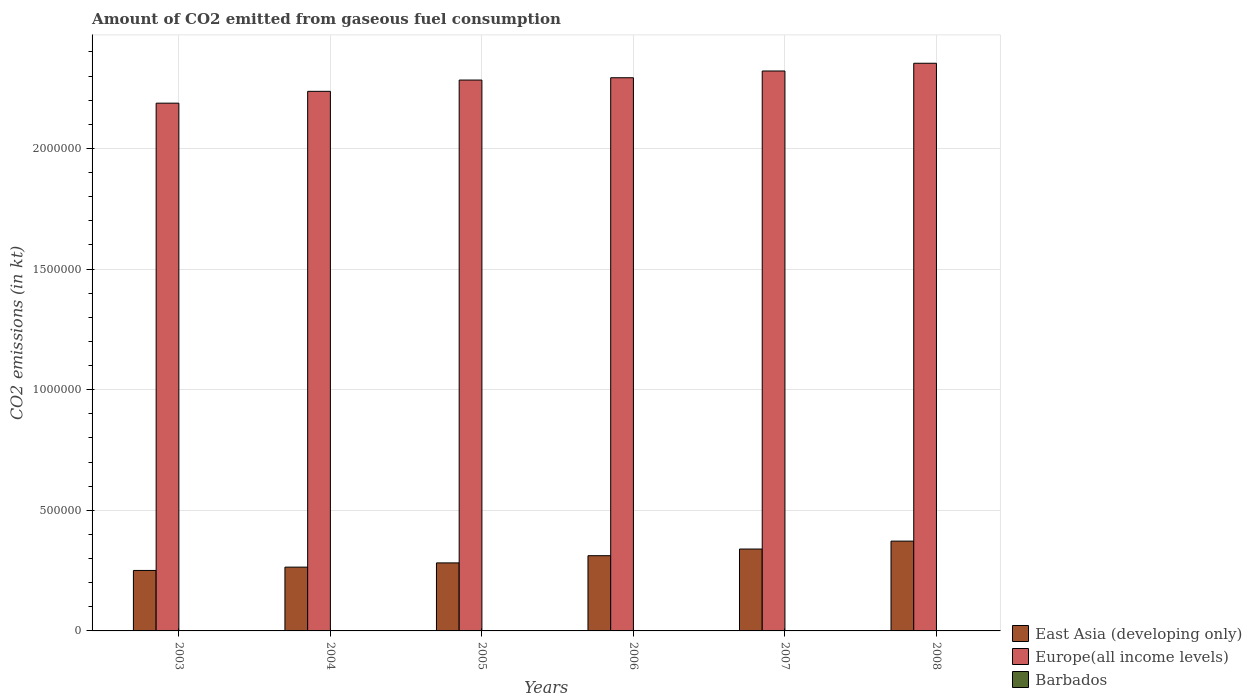Are the number of bars on each tick of the X-axis equal?
Provide a short and direct response. Yes. In how many cases, is the number of bars for a given year not equal to the number of legend labels?
Make the answer very short. 0. What is the amount of CO2 emitted in Europe(all income levels) in 2004?
Keep it short and to the point. 2.24e+06. Across all years, what is the maximum amount of CO2 emitted in Barbados?
Provide a succinct answer. 51.34. Across all years, what is the minimum amount of CO2 emitted in Barbados?
Offer a very short reply. 44. In which year was the amount of CO2 emitted in Barbados maximum?
Offer a terse response. 2005. What is the total amount of CO2 emitted in Barbados in the graph?
Keep it short and to the point. 293.36. What is the difference between the amount of CO2 emitted in East Asia (developing only) in 2004 and that in 2006?
Offer a terse response. -4.74e+04. What is the difference between the amount of CO2 emitted in Europe(all income levels) in 2008 and the amount of CO2 emitted in Barbados in 2005?
Keep it short and to the point. 2.35e+06. What is the average amount of CO2 emitted in Barbados per year?
Provide a succinct answer. 48.89. In the year 2005, what is the difference between the amount of CO2 emitted in Barbados and amount of CO2 emitted in Europe(all income levels)?
Offer a terse response. -2.28e+06. What is the ratio of the amount of CO2 emitted in East Asia (developing only) in 2005 to that in 2007?
Ensure brevity in your answer.  0.83. Is the amount of CO2 emitted in East Asia (developing only) in 2003 less than that in 2007?
Give a very brief answer. Yes. Is the difference between the amount of CO2 emitted in Barbados in 2003 and 2005 greater than the difference between the amount of CO2 emitted in Europe(all income levels) in 2003 and 2005?
Make the answer very short. Yes. What is the difference between the highest and the lowest amount of CO2 emitted in Barbados?
Your answer should be compact. 7.33. What does the 1st bar from the left in 2006 represents?
Your answer should be compact. East Asia (developing only). What does the 3rd bar from the right in 2006 represents?
Your answer should be very brief. East Asia (developing only). Is it the case that in every year, the sum of the amount of CO2 emitted in Europe(all income levels) and amount of CO2 emitted in Barbados is greater than the amount of CO2 emitted in East Asia (developing only)?
Provide a short and direct response. Yes. How many bars are there?
Ensure brevity in your answer.  18. Are all the bars in the graph horizontal?
Give a very brief answer. No. How many years are there in the graph?
Your answer should be very brief. 6. What is the difference between two consecutive major ticks on the Y-axis?
Your answer should be compact. 5.00e+05. Does the graph contain grids?
Keep it short and to the point. Yes. Where does the legend appear in the graph?
Offer a very short reply. Bottom right. How are the legend labels stacked?
Make the answer very short. Vertical. What is the title of the graph?
Your answer should be compact. Amount of CO2 emitted from gaseous fuel consumption. Does "India" appear as one of the legend labels in the graph?
Ensure brevity in your answer.  No. What is the label or title of the X-axis?
Ensure brevity in your answer.  Years. What is the label or title of the Y-axis?
Keep it short and to the point. CO2 emissions (in kt). What is the CO2 emissions (in kt) of East Asia (developing only) in 2003?
Ensure brevity in your answer.  2.51e+05. What is the CO2 emissions (in kt) in Europe(all income levels) in 2003?
Give a very brief answer. 2.19e+06. What is the CO2 emissions (in kt) of Barbados in 2003?
Ensure brevity in your answer.  47.67. What is the CO2 emissions (in kt) of East Asia (developing only) in 2004?
Your answer should be very brief. 2.64e+05. What is the CO2 emissions (in kt) of Europe(all income levels) in 2004?
Offer a very short reply. 2.24e+06. What is the CO2 emissions (in kt) in Barbados in 2004?
Offer a very short reply. 47.67. What is the CO2 emissions (in kt) of East Asia (developing only) in 2005?
Ensure brevity in your answer.  2.82e+05. What is the CO2 emissions (in kt) in Europe(all income levels) in 2005?
Your answer should be compact. 2.28e+06. What is the CO2 emissions (in kt) of Barbados in 2005?
Offer a very short reply. 51.34. What is the CO2 emissions (in kt) in East Asia (developing only) in 2006?
Keep it short and to the point. 3.12e+05. What is the CO2 emissions (in kt) in Europe(all income levels) in 2006?
Your answer should be very brief. 2.29e+06. What is the CO2 emissions (in kt) of Barbados in 2006?
Make the answer very short. 51.34. What is the CO2 emissions (in kt) in East Asia (developing only) in 2007?
Provide a short and direct response. 3.39e+05. What is the CO2 emissions (in kt) of Europe(all income levels) in 2007?
Provide a short and direct response. 2.32e+06. What is the CO2 emissions (in kt) of Barbados in 2007?
Offer a terse response. 44. What is the CO2 emissions (in kt) in East Asia (developing only) in 2008?
Keep it short and to the point. 3.72e+05. What is the CO2 emissions (in kt) of Europe(all income levels) in 2008?
Your answer should be very brief. 2.35e+06. What is the CO2 emissions (in kt) of Barbados in 2008?
Ensure brevity in your answer.  51.34. Across all years, what is the maximum CO2 emissions (in kt) in East Asia (developing only)?
Make the answer very short. 3.72e+05. Across all years, what is the maximum CO2 emissions (in kt) of Europe(all income levels)?
Keep it short and to the point. 2.35e+06. Across all years, what is the maximum CO2 emissions (in kt) in Barbados?
Provide a succinct answer. 51.34. Across all years, what is the minimum CO2 emissions (in kt) of East Asia (developing only)?
Make the answer very short. 2.51e+05. Across all years, what is the minimum CO2 emissions (in kt) in Europe(all income levels)?
Your response must be concise. 2.19e+06. Across all years, what is the minimum CO2 emissions (in kt) in Barbados?
Your answer should be very brief. 44. What is the total CO2 emissions (in kt) of East Asia (developing only) in the graph?
Provide a succinct answer. 1.82e+06. What is the total CO2 emissions (in kt) in Europe(all income levels) in the graph?
Give a very brief answer. 1.37e+07. What is the total CO2 emissions (in kt) of Barbados in the graph?
Provide a succinct answer. 293.36. What is the difference between the CO2 emissions (in kt) of East Asia (developing only) in 2003 and that in 2004?
Give a very brief answer. -1.37e+04. What is the difference between the CO2 emissions (in kt) of Europe(all income levels) in 2003 and that in 2004?
Keep it short and to the point. -4.90e+04. What is the difference between the CO2 emissions (in kt) of Barbados in 2003 and that in 2004?
Keep it short and to the point. 0. What is the difference between the CO2 emissions (in kt) in East Asia (developing only) in 2003 and that in 2005?
Keep it short and to the point. -3.13e+04. What is the difference between the CO2 emissions (in kt) in Europe(all income levels) in 2003 and that in 2005?
Provide a short and direct response. -9.58e+04. What is the difference between the CO2 emissions (in kt) of Barbados in 2003 and that in 2005?
Offer a terse response. -3.67. What is the difference between the CO2 emissions (in kt) in East Asia (developing only) in 2003 and that in 2006?
Ensure brevity in your answer.  -6.11e+04. What is the difference between the CO2 emissions (in kt) in Europe(all income levels) in 2003 and that in 2006?
Provide a succinct answer. -1.05e+05. What is the difference between the CO2 emissions (in kt) of Barbados in 2003 and that in 2006?
Keep it short and to the point. -3.67. What is the difference between the CO2 emissions (in kt) in East Asia (developing only) in 2003 and that in 2007?
Give a very brief answer. -8.87e+04. What is the difference between the CO2 emissions (in kt) in Europe(all income levels) in 2003 and that in 2007?
Provide a succinct answer. -1.33e+05. What is the difference between the CO2 emissions (in kt) of Barbados in 2003 and that in 2007?
Make the answer very short. 3.67. What is the difference between the CO2 emissions (in kt) in East Asia (developing only) in 2003 and that in 2008?
Your answer should be very brief. -1.22e+05. What is the difference between the CO2 emissions (in kt) in Europe(all income levels) in 2003 and that in 2008?
Offer a very short reply. -1.65e+05. What is the difference between the CO2 emissions (in kt) in Barbados in 2003 and that in 2008?
Offer a terse response. -3.67. What is the difference between the CO2 emissions (in kt) of East Asia (developing only) in 2004 and that in 2005?
Make the answer very short. -1.76e+04. What is the difference between the CO2 emissions (in kt) in Europe(all income levels) in 2004 and that in 2005?
Make the answer very short. -4.68e+04. What is the difference between the CO2 emissions (in kt) of Barbados in 2004 and that in 2005?
Give a very brief answer. -3.67. What is the difference between the CO2 emissions (in kt) of East Asia (developing only) in 2004 and that in 2006?
Your response must be concise. -4.74e+04. What is the difference between the CO2 emissions (in kt) in Europe(all income levels) in 2004 and that in 2006?
Offer a very short reply. -5.64e+04. What is the difference between the CO2 emissions (in kt) of Barbados in 2004 and that in 2006?
Your response must be concise. -3.67. What is the difference between the CO2 emissions (in kt) of East Asia (developing only) in 2004 and that in 2007?
Provide a short and direct response. -7.50e+04. What is the difference between the CO2 emissions (in kt) of Europe(all income levels) in 2004 and that in 2007?
Your answer should be very brief. -8.43e+04. What is the difference between the CO2 emissions (in kt) in Barbados in 2004 and that in 2007?
Ensure brevity in your answer.  3.67. What is the difference between the CO2 emissions (in kt) of East Asia (developing only) in 2004 and that in 2008?
Keep it short and to the point. -1.08e+05. What is the difference between the CO2 emissions (in kt) of Europe(all income levels) in 2004 and that in 2008?
Your answer should be compact. -1.16e+05. What is the difference between the CO2 emissions (in kt) in Barbados in 2004 and that in 2008?
Provide a short and direct response. -3.67. What is the difference between the CO2 emissions (in kt) in East Asia (developing only) in 2005 and that in 2006?
Provide a succinct answer. -2.99e+04. What is the difference between the CO2 emissions (in kt) of Europe(all income levels) in 2005 and that in 2006?
Your answer should be very brief. -9615.06. What is the difference between the CO2 emissions (in kt) of Barbados in 2005 and that in 2006?
Offer a very short reply. 0. What is the difference between the CO2 emissions (in kt) of East Asia (developing only) in 2005 and that in 2007?
Give a very brief answer. -5.74e+04. What is the difference between the CO2 emissions (in kt) of Europe(all income levels) in 2005 and that in 2007?
Your answer should be very brief. -3.75e+04. What is the difference between the CO2 emissions (in kt) of Barbados in 2005 and that in 2007?
Provide a short and direct response. 7.33. What is the difference between the CO2 emissions (in kt) of East Asia (developing only) in 2005 and that in 2008?
Make the answer very short. -9.03e+04. What is the difference between the CO2 emissions (in kt) of Europe(all income levels) in 2005 and that in 2008?
Offer a very short reply. -6.96e+04. What is the difference between the CO2 emissions (in kt) of Barbados in 2005 and that in 2008?
Your response must be concise. 0. What is the difference between the CO2 emissions (in kt) of East Asia (developing only) in 2006 and that in 2007?
Provide a short and direct response. -2.75e+04. What is the difference between the CO2 emissions (in kt) of Europe(all income levels) in 2006 and that in 2007?
Give a very brief answer. -2.79e+04. What is the difference between the CO2 emissions (in kt) of Barbados in 2006 and that in 2007?
Offer a very short reply. 7.33. What is the difference between the CO2 emissions (in kt) in East Asia (developing only) in 2006 and that in 2008?
Offer a very short reply. -6.04e+04. What is the difference between the CO2 emissions (in kt) in Europe(all income levels) in 2006 and that in 2008?
Offer a very short reply. -6.00e+04. What is the difference between the CO2 emissions (in kt) in Barbados in 2006 and that in 2008?
Make the answer very short. 0. What is the difference between the CO2 emissions (in kt) in East Asia (developing only) in 2007 and that in 2008?
Provide a succinct answer. -3.29e+04. What is the difference between the CO2 emissions (in kt) of Europe(all income levels) in 2007 and that in 2008?
Keep it short and to the point. -3.21e+04. What is the difference between the CO2 emissions (in kt) of Barbados in 2007 and that in 2008?
Your answer should be very brief. -7.33. What is the difference between the CO2 emissions (in kt) of East Asia (developing only) in 2003 and the CO2 emissions (in kt) of Europe(all income levels) in 2004?
Keep it short and to the point. -1.99e+06. What is the difference between the CO2 emissions (in kt) of East Asia (developing only) in 2003 and the CO2 emissions (in kt) of Barbados in 2004?
Ensure brevity in your answer.  2.51e+05. What is the difference between the CO2 emissions (in kt) in Europe(all income levels) in 2003 and the CO2 emissions (in kt) in Barbados in 2004?
Keep it short and to the point. 2.19e+06. What is the difference between the CO2 emissions (in kt) of East Asia (developing only) in 2003 and the CO2 emissions (in kt) of Europe(all income levels) in 2005?
Your response must be concise. -2.03e+06. What is the difference between the CO2 emissions (in kt) in East Asia (developing only) in 2003 and the CO2 emissions (in kt) in Barbados in 2005?
Keep it short and to the point. 2.51e+05. What is the difference between the CO2 emissions (in kt) in Europe(all income levels) in 2003 and the CO2 emissions (in kt) in Barbados in 2005?
Your response must be concise. 2.19e+06. What is the difference between the CO2 emissions (in kt) of East Asia (developing only) in 2003 and the CO2 emissions (in kt) of Europe(all income levels) in 2006?
Provide a short and direct response. -2.04e+06. What is the difference between the CO2 emissions (in kt) of East Asia (developing only) in 2003 and the CO2 emissions (in kt) of Barbados in 2006?
Provide a succinct answer. 2.51e+05. What is the difference between the CO2 emissions (in kt) of Europe(all income levels) in 2003 and the CO2 emissions (in kt) of Barbados in 2006?
Your answer should be very brief. 2.19e+06. What is the difference between the CO2 emissions (in kt) of East Asia (developing only) in 2003 and the CO2 emissions (in kt) of Europe(all income levels) in 2007?
Make the answer very short. -2.07e+06. What is the difference between the CO2 emissions (in kt) of East Asia (developing only) in 2003 and the CO2 emissions (in kt) of Barbados in 2007?
Your answer should be compact. 2.51e+05. What is the difference between the CO2 emissions (in kt) in Europe(all income levels) in 2003 and the CO2 emissions (in kt) in Barbados in 2007?
Your response must be concise. 2.19e+06. What is the difference between the CO2 emissions (in kt) in East Asia (developing only) in 2003 and the CO2 emissions (in kt) in Europe(all income levels) in 2008?
Provide a short and direct response. -2.10e+06. What is the difference between the CO2 emissions (in kt) of East Asia (developing only) in 2003 and the CO2 emissions (in kt) of Barbados in 2008?
Provide a short and direct response. 2.51e+05. What is the difference between the CO2 emissions (in kt) of Europe(all income levels) in 2003 and the CO2 emissions (in kt) of Barbados in 2008?
Keep it short and to the point. 2.19e+06. What is the difference between the CO2 emissions (in kt) in East Asia (developing only) in 2004 and the CO2 emissions (in kt) in Europe(all income levels) in 2005?
Give a very brief answer. -2.02e+06. What is the difference between the CO2 emissions (in kt) of East Asia (developing only) in 2004 and the CO2 emissions (in kt) of Barbados in 2005?
Give a very brief answer. 2.64e+05. What is the difference between the CO2 emissions (in kt) of Europe(all income levels) in 2004 and the CO2 emissions (in kt) of Barbados in 2005?
Ensure brevity in your answer.  2.24e+06. What is the difference between the CO2 emissions (in kt) in East Asia (developing only) in 2004 and the CO2 emissions (in kt) in Europe(all income levels) in 2006?
Offer a very short reply. -2.03e+06. What is the difference between the CO2 emissions (in kt) of East Asia (developing only) in 2004 and the CO2 emissions (in kt) of Barbados in 2006?
Give a very brief answer. 2.64e+05. What is the difference between the CO2 emissions (in kt) of Europe(all income levels) in 2004 and the CO2 emissions (in kt) of Barbados in 2006?
Keep it short and to the point. 2.24e+06. What is the difference between the CO2 emissions (in kt) of East Asia (developing only) in 2004 and the CO2 emissions (in kt) of Europe(all income levels) in 2007?
Keep it short and to the point. -2.06e+06. What is the difference between the CO2 emissions (in kt) in East Asia (developing only) in 2004 and the CO2 emissions (in kt) in Barbados in 2007?
Ensure brevity in your answer.  2.64e+05. What is the difference between the CO2 emissions (in kt) of Europe(all income levels) in 2004 and the CO2 emissions (in kt) of Barbados in 2007?
Provide a succinct answer. 2.24e+06. What is the difference between the CO2 emissions (in kt) in East Asia (developing only) in 2004 and the CO2 emissions (in kt) in Europe(all income levels) in 2008?
Make the answer very short. -2.09e+06. What is the difference between the CO2 emissions (in kt) of East Asia (developing only) in 2004 and the CO2 emissions (in kt) of Barbados in 2008?
Your answer should be compact. 2.64e+05. What is the difference between the CO2 emissions (in kt) of Europe(all income levels) in 2004 and the CO2 emissions (in kt) of Barbados in 2008?
Your answer should be very brief. 2.24e+06. What is the difference between the CO2 emissions (in kt) in East Asia (developing only) in 2005 and the CO2 emissions (in kt) in Europe(all income levels) in 2006?
Offer a terse response. -2.01e+06. What is the difference between the CO2 emissions (in kt) in East Asia (developing only) in 2005 and the CO2 emissions (in kt) in Barbados in 2006?
Keep it short and to the point. 2.82e+05. What is the difference between the CO2 emissions (in kt) of Europe(all income levels) in 2005 and the CO2 emissions (in kt) of Barbados in 2006?
Give a very brief answer. 2.28e+06. What is the difference between the CO2 emissions (in kt) in East Asia (developing only) in 2005 and the CO2 emissions (in kt) in Europe(all income levels) in 2007?
Provide a short and direct response. -2.04e+06. What is the difference between the CO2 emissions (in kt) in East Asia (developing only) in 2005 and the CO2 emissions (in kt) in Barbados in 2007?
Keep it short and to the point. 2.82e+05. What is the difference between the CO2 emissions (in kt) in Europe(all income levels) in 2005 and the CO2 emissions (in kt) in Barbados in 2007?
Your answer should be very brief. 2.28e+06. What is the difference between the CO2 emissions (in kt) of East Asia (developing only) in 2005 and the CO2 emissions (in kt) of Europe(all income levels) in 2008?
Offer a very short reply. -2.07e+06. What is the difference between the CO2 emissions (in kt) of East Asia (developing only) in 2005 and the CO2 emissions (in kt) of Barbados in 2008?
Offer a terse response. 2.82e+05. What is the difference between the CO2 emissions (in kt) in Europe(all income levels) in 2005 and the CO2 emissions (in kt) in Barbados in 2008?
Your response must be concise. 2.28e+06. What is the difference between the CO2 emissions (in kt) of East Asia (developing only) in 2006 and the CO2 emissions (in kt) of Europe(all income levels) in 2007?
Offer a very short reply. -2.01e+06. What is the difference between the CO2 emissions (in kt) of East Asia (developing only) in 2006 and the CO2 emissions (in kt) of Barbados in 2007?
Keep it short and to the point. 3.12e+05. What is the difference between the CO2 emissions (in kt) of Europe(all income levels) in 2006 and the CO2 emissions (in kt) of Barbados in 2007?
Provide a short and direct response. 2.29e+06. What is the difference between the CO2 emissions (in kt) in East Asia (developing only) in 2006 and the CO2 emissions (in kt) in Europe(all income levels) in 2008?
Your answer should be compact. -2.04e+06. What is the difference between the CO2 emissions (in kt) of East Asia (developing only) in 2006 and the CO2 emissions (in kt) of Barbados in 2008?
Provide a succinct answer. 3.12e+05. What is the difference between the CO2 emissions (in kt) in Europe(all income levels) in 2006 and the CO2 emissions (in kt) in Barbados in 2008?
Provide a succinct answer. 2.29e+06. What is the difference between the CO2 emissions (in kt) in East Asia (developing only) in 2007 and the CO2 emissions (in kt) in Europe(all income levels) in 2008?
Ensure brevity in your answer.  -2.01e+06. What is the difference between the CO2 emissions (in kt) of East Asia (developing only) in 2007 and the CO2 emissions (in kt) of Barbados in 2008?
Give a very brief answer. 3.39e+05. What is the difference between the CO2 emissions (in kt) of Europe(all income levels) in 2007 and the CO2 emissions (in kt) of Barbados in 2008?
Give a very brief answer. 2.32e+06. What is the average CO2 emissions (in kt) in East Asia (developing only) per year?
Offer a terse response. 3.03e+05. What is the average CO2 emissions (in kt) in Europe(all income levels) per year?
Give a very brief answer. 2.28e+06. What is the average CO2 emissions (in kt) of Barbados per year?
Provide a succinct answer. 48.89. In the year 2003, what is the difference between the CO2 emissions (in kt) in East Asia (developing only) and CO2 emissions (in kt) in Europe(all income levels)?
Offer a very short reply. -1.94e+06. In the year 2003, what is the difference between the CO2 emissions (in kt) of East Asia (developing only) and CO2 emissions (in kt) of Barbados?
Give a very brief answer. 2.51e+05. In the year 2003, what is the difference between the CO2 emissions (in kt) of Europe(all income levels) and CO2 emissions (in kt) of Barbados?
Your response must be concise. 2.19e+06. In the year 2004, what is the difference between the CO2 emissions (in kt) in East Asia (developing only) and CO2 emissions (in kt) in Europe(all income levels)?
Offer a terse response. -1.97e+06. In the year 2004, what is the difference between the CO2 emissions (in kt) in East Asia (developing only) and CO2 emissions (in kt) in Barbados?
Offer a very short reply. 2.64e+05. In the year 2004, what is the difference between the CO2 emissions (in kt) in Europe(all income levels) and CO2 emissions (in kt) in Barbados?
Provide a succinct answer. 2.24e+06. In the year 2005, what is the difference between the CO2 emissions (in kt) in East Asia (developing only) and CO2 emissions (in kt) in Europe(all income levels)?
Offer a terse response. -2.00e+06. In the year 2005, what is the difference between the CO2 emissions (in kt) in East Asia (developing only) and CO2 emissions (in kt) in Barbados?
Give a very brief answer. 2.82e+05. In the year 2005, what is the difference between the CO2 emissions (in kt) of Europe(all income levels) and CO2 emissions (in kt) of Barbados?
Provide a short and direct response. 2.28e+06. In the year 2006, what is the difference between the CO2 emissions (in kt) in East Asia (developing only) and CO2 emissions (in kt) in Europe(all income levels)?
Give a very brief answer. -1.98e+06. In the year 2006, what is the difference between the CO2 emissions (in kt) of East Asia (developing only) and CO2 emissions (in kt) of Barbados?
Provide a succinct answer. 3.12e+05. In the year 2006, what is the difference between the CO2 emissions (in kt) of Europe(all income levels) and CO2 emissions (in kt) of Barbados?
Provide a short and direct response. 2.29e+06. In the year 2007, what is the difference between the CO2 emissions (in kt) in East Asia (developing only) and CO2 emissions (in kt) in Europe(all income levels)?
Provide a succinct answer. -1.98e+06. In the year 2007, what is the difference between the CO2 emissions (in kt) of East Asia (developing only) and CO2 emissions (in kt) of Barbados?
Your response must be concise. 3.39e+05. In the year 2007, what is the difference between the CO2 emissions (in kt) of Europe(all income levels) and CO2 emissions (in kt) of Barbados?
Offer a terse response. 2.32e+06. In the year 2008, what is the difference between the CO2 emissions (in kt) of East Asia (developing only) and CO2 emissions (in kt) of Europe(all income levels)?
Offer a very short reply. -1.98e+06. In the year 2008, what is the difference between the CO2 emissions (in kt) in East Asia (developing only) and CO2 emissions (in kt) in Barbados?
Offer a very short reply. 3.72e+05. In the year 2008, what is the difference between the CO2 emissions (in kt) of Europe(all income levels) and CO2 emissions (in kt) of Barbados?
Ensure brevity in your answer.  2.35e+06. What is the ratio of the CO2 emissions (in kt) of East Asia (developing only) in 2003 to that in 2004?
Keep it short and to the point. 0.95. What is the ratio of the CO2 emissions (in kt) in Europe(all income levels) in 2003 to that in 2004?
Your answer should be compact. 0.98. What is the ratio of the CO2 emissions (in kt) of Barbados in 2003 to that in 2004?
Make the answer very short. 1. What is the ratio of the CO2 emissions (in kt) in East Asia (developing only) in 2003 to that in 2005?
Offer a terse response. 0.89. What is the ratio of the CO2 emissions (in kt) in Europe(all income levels) in 2003 to that in 2005?
Provide a short and direct response. 0.96. What is the ratio of the CO2 emissions (in kt) of East Asia (developing only) in 2003 to that in 2006?
Provide a short and direct response. 0.8. What is the ratio of the CO2 emissions (in kt) of Europe(all income levels) in 2003 to that in 2006?
Your response must be concise. 0.95. What is the ratio of the CO2 emissions (in kt) in Barbados in 2003 to that in 2006?
Offer a terse response. 0.93. What is the ratio of the CO2 emissions (in kt) of East Asia (developing only) in 2003 to that in 2007?
Offer a terse response. 0.74. What is the ratio of the CO2 emissions (in kt) in Europe(all income levels) in 2003 to that in 2007?
Offer a terse response. 0.94. What is the ratio of the CO2 emissions (in kt) of Barbados in 2003 to that in 2007?
Make the answer very short. 1.08. What is the ratio of the CO2 emissions (in kt) in East Asia (developing only) in 2003 to that in 2008?
Offer a very short reply. 0.67. What is the ratio of the CO2 emissions (in kt) of Europe(all income levels) in 2003 to that in 2008?
Make the answer very short. 0.93. What is the ratio of the CO2 emissions (in kt) in Barbados in 2003 to that in 2008?
Your answer should be very brief. 0.93. What is the ratio of the CO2 emissions (in kt) of East Asia (developing only) in 2004 to that in 2005?
Your answer should be compact. 0.94. What is the ratio of the CO2 emissions (in kt) of Europe(all income levels) in 2004 to that in 2005?
Your answer should be compact. 0.98. What is the ratio of the CO2 emissions (in kt) in East Asia (developing only) in 2004 to that in 2006?
Provide a succinct answer. 0.85. What is the ratio of the CO2 emissions (in kt) in Europe(all income levels) in 2004 to that in 2006?
Ensure brevity in your answer.  0.98. What is the ratio of the CO2 emissions (in kt) of East Asia (developing only) in 2004 to that in 2007?
Your response must be concise. 0.78. What is the ratio of the CO2 emissions (in kt) in Europe(all income levels) in 2004 to that in 2007?
Your answer should be very brief. 0.96. What is the ratio of the CO2 emissions (in kt) of East Asia (developing only) in 2004 to that in 2008?
Keep it short and to the point. 0.71. What is the ratio of the CO2 emissions (in kt) in Europe(all income levels) in 2004 to that in 2008?
Offer a very short reply. 0.95. What is the ratio of the CO2 emissions (in kt) of Barbados in 2004 to that in 2008?
Your answer should be compact. 0.93. What is the ratio of the CO2 emissions (in kt) in East Asia (developing only) in 2005 to that in 2006?
Your answer should be very brief. 0.9. What is the ratio of the CO2 emissions (in kt) of East Asia (developing only) in 2005 to that in 2007?
Provide a short and direct response. 0.83. What is the ratio of the CO2 emissions (in kt) of Europe(all income levels) in 2005 to that in 2007?
Your answer should be very brief. 0.98. What is the ratio of the CO2 emissions (in kt) of Barbados in 2005 to that in 2007?
Provide a short and direct response. 1.17. What is the ratio of the CO2 emissions (in kt) in East Asia (developing only) in 2005 to that in 2008?
Provide a succinct answer. 0.76. What is the ratio of the CO2 emissions (in kt) of Europe(all income levels) in 2005 to that in 2008?
Offer a terse response. 0.97. What is the ratio of the CO2 emissions (in kt) in East Asia (developing only) in 2006 to that in 2007?
Provide a short and direct response. 0.92. What is the ratio of the CO2 emissions (in kt) of Europe(all income levels) in 2006 to that in 2007?
Keep it short and to the point. 0.99. What is the ratio of the CO2 emissions (in kt) in Barbados in 2006 to that in 2007?
Make the answer very short. 1.17. What is the ratio of the CO2 emissions (in kt) of East Asia (developing only) in 2006 to that in 2008?
Your response must be concise. 0.84. What is the ratio of the CO2 emissions (in kt) in Europe(all income levels) in 2006 to that in 2008?
Provide a short and direct response. 0.97. What is the ratio of the CO2 emissions (in kt) in East Asia (developing only) in 2007 to that in 2008?
Make the answer very short. 0.91. What is the ratio of the CO2 emissions (in kt) of Europe(all income levels) in 2007 to that in 2008?
Make the answer very short. 0.99. What is the difference between the highest and the second highest CO2 emissions (in kt) of East Asia (developing only)?
Give a very brief answer. 3.29e+04. What is the difference between the highest and the second highest CO2 emissions (in kt) of Europe(all income levels)?
Provide a succinct answer. 3.21e+04. What is the difference between the highest and the lowest CO2 emissions (in kt) of East Asia (developing only)?
Ensure brevity in your answer.  1.22e+05. What is the difference between the highest and the lowest CO2 emissions (in kt) of Europe(all income levels)?
Your answer should be compact. 1.65e+05. What is the difference between the highest and the lowest CO2 emissions (in kt) in Barbados?
Make the answer very short. 7.33. 